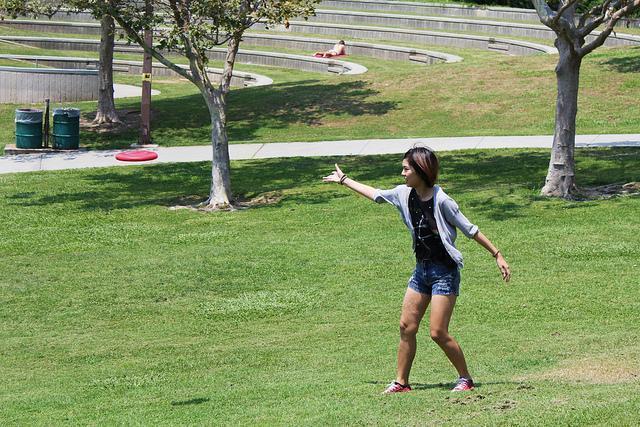How many garbage cans can you see?
Give a very brief answer. 2. How many people are wearing a tie in the picture?
Give a very brief answer. 0. 